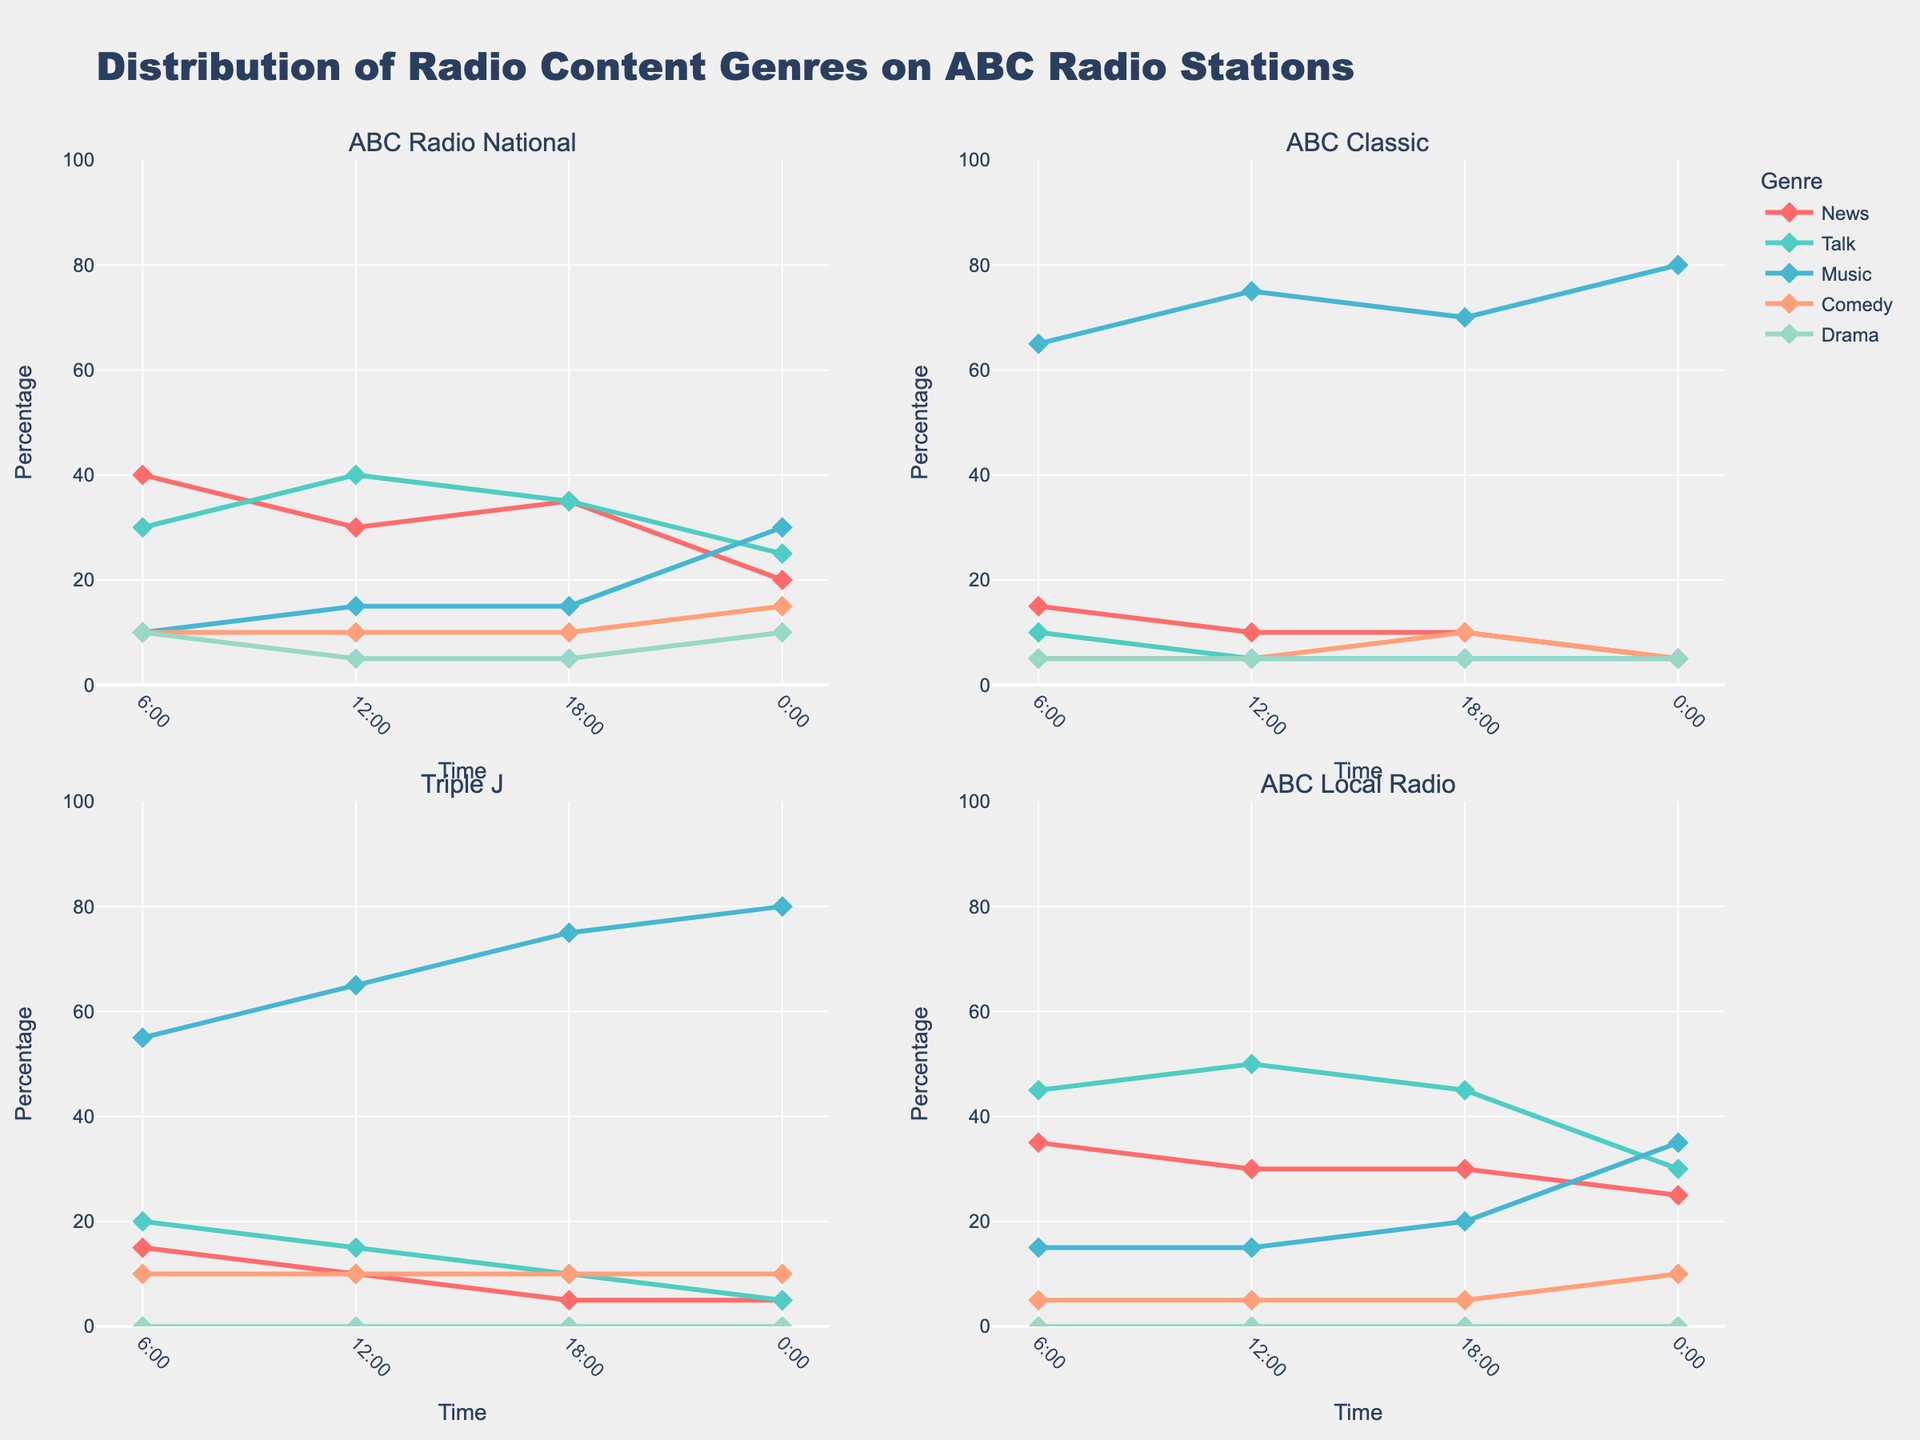What is the title of the figure? The title is usually located at the top of the figure. This specific title reads "Evolution of Coin Minting Techniques in Medieval Times."
Answer: Evolution of Coin Minting Techniques in Medieval Times What are the start and end years of the timeline? The x-axis of the figure represents years with a range. In this case, it shows a range from 450 AD to 1550 AD.
Answer: 450 AD to 1550 AD Which minting technique appears earliest in the timeline? By examining the leftmost bars on the horizontal timeline, Hammering and Casting techniques both start at 500 AD.
Answer: Hammering and Casting Which coin minting technique has the longest duration on the timeline? To determine the longest duration, you need to look for the bar that spans the most years. The Casting technique lasts from 500 AD to 1500 AD, thus spanning 1000 years.
Answer: Casting How long did the Scyphate technique last? Find the bar labeled Scyphate and check its start and end points. It starts at 1000 AD and ends at 1204 AD, giving it a duration of 204 years.
Answer: 204 years Which techniques were in use simultaneously around 1200 AD? Locate the 1200 AD mark on the x-axis and identify which bars span over this point. Techniques such as Scyphate, Bracteates, and Casting were in use around this time.
Answer: Scyphate, Bracteates, Casting Which technique had the shortest duration on the timeline? By comparing the lengths of all the bars, Millares appears to have the shortest span, lasting from 1100 AD to 1300 AD, which is 200 years.
Answer: Millares How many techniques were still in use by the year 1500 AD? Look for bars that extend up to or beyond the 1500 AD mark on the x-axis. Techniques that reach this year include Casting, Groat Production, Penny Striking, Gold Florin Minting, and Sterling Silver.
Answer: 5 techniques What is the total duration of the Denier Tournois technique? Find the bar labeled Denier Tournois and check its start and end points. It starts at 800 AD and ends at 1350 AD, making its duration 550 years.
Answer: 550 years When did the Groat Production technique start, and how long did it last? Locate the Groat Production bar to determine the start year as 1266 AD. The bar ends at 1500 AD, so it lasted 234 years.
Answer: 1266 AD, 234 years 